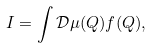Convert formula to latex. <formula><loc_0><loc_0><loc_500><loc_500>I = \int \mathcal { D } \mu ( Q ) f ( Q ) ,</formula> 